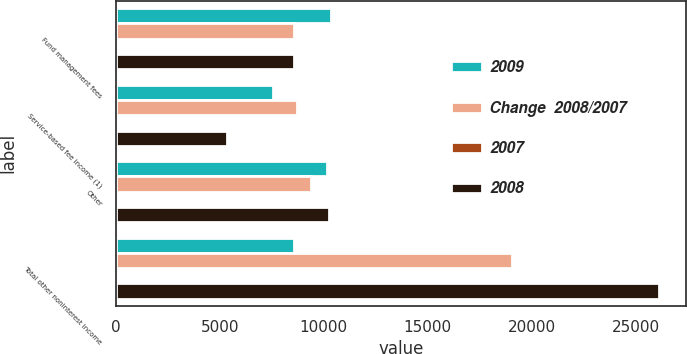Convert chart to OTSL. <chart><loc_0><loc_0><loc_500><loc_500><stacked_bar_chart><ecel><fcel>Fund management fees<fcel>Service-based fee income (1)<fcel>Other<fcel>Total other noninterest income<nl><fcel>2009<fcel>10328<fcel>7554<fcel>10134<fcel>8583<nl><fcel>Change  2008/2007<fcel>8547<fcel>8686<fcel>9386<fcel>19052<nl><fcel>2007<fcel>20.8<fcel>13<fcel>8<fcel>57.3<nl><fcel>2008<fcel>8583<fcel>5356<fcel>10252<fcel>26096<nl></chart> 